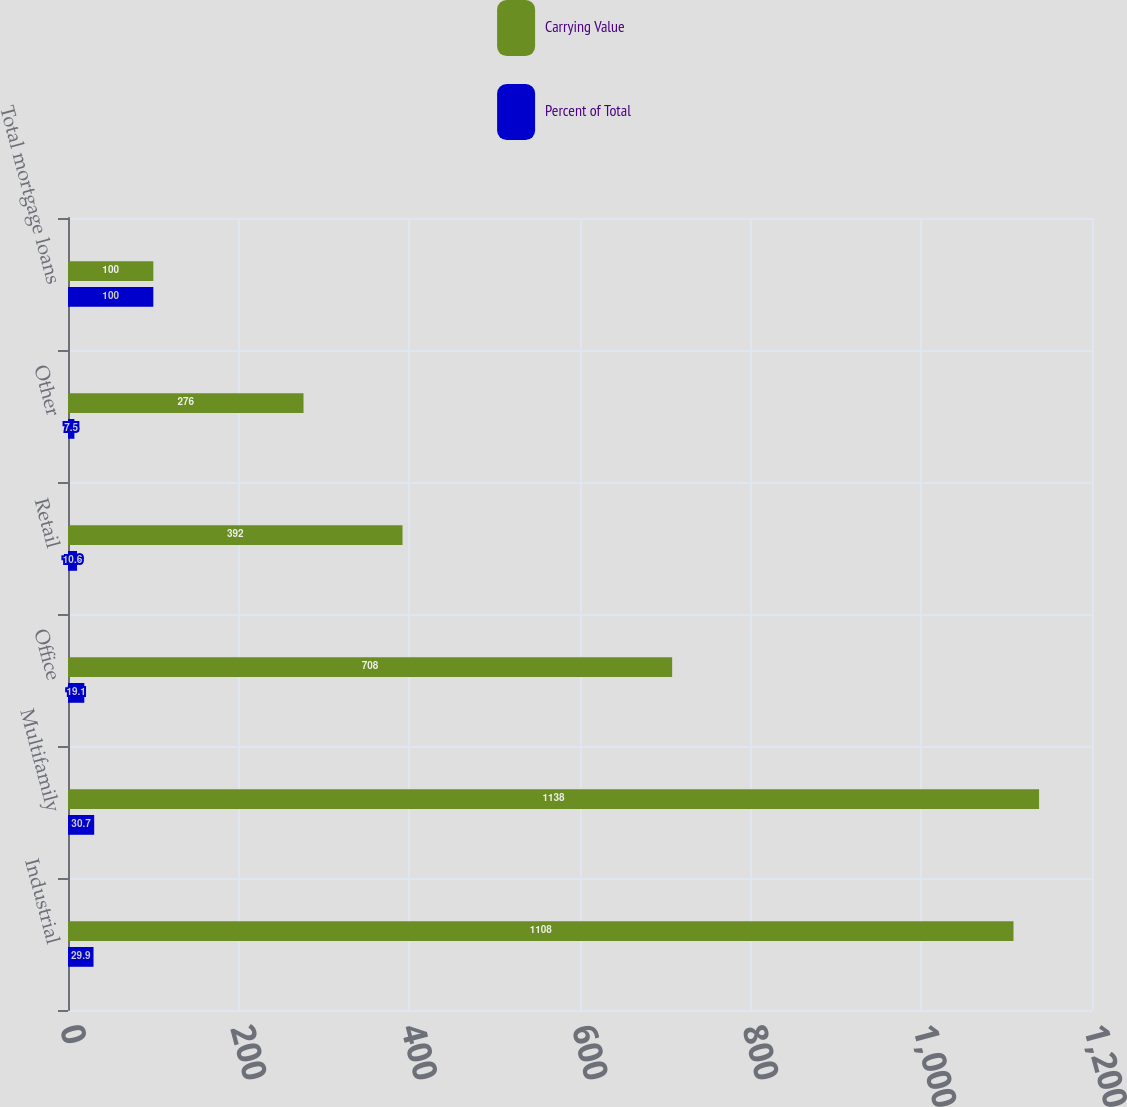<chart> <loc_0><loc_0><loc_500><loc_500><stacked_bar_chart><ecel><fcel>Industrial<fcel>Multifamily<fcel>Office<fcel>Retail<fcel>Other<fcel>Total mortgage loans<nl><fcel>Carrying Value<fcel>1108<fcel>1138<fcel>708<fcel>392<fcel>276<fcel>100<nl><fcel>Percent of Total<fcel>29.9<fcel>30.7<fcel>19.1<fcel>10.6<fcel>7.5<fcel>100<nl></chart> 